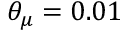<formula> <loc_0><loc_0><loc_500><loc_500>\theta _ { \mu } = 0 . 0 1</formula> 